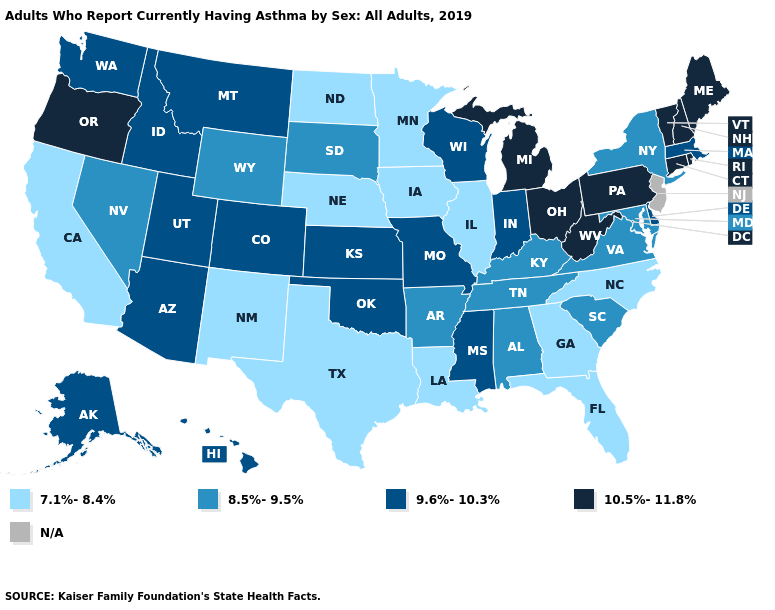Is the legend a continuous bar?
Give a very brief answer. No. What is the value of Alabama?
Concise answer only. 8.5%-9.5%. Name the states that have a value in the range N/A?
Quick response, please. New Jersey. How many symbols are there in the legend?
Keep it brief. 5. What is the value of Kentucky?
Quick response, please. 8.5%-9.5%. Among the states that border Massachusetts , does New York have the lowest value?
Short answer required. Yes. Which states have the highest value in the USA?
Concise answer only. Connecticut, Maine, Michigan, New Hampshire, Ohio, Oregon, Pennsylvania, Rhode Island, Vermont, West Virginia. Name the states that have a value in the range 7.1%-8.4%?
Keep it brief. California, Florida, Georgia, Illinois, Iowa, Louisiana, Minnesota, Nebraska, New Mexico, North Carolina, North Dakota, Texas. What is the value of Kansas?
Keep it brief. 9.6%-10.3%. Does the first symbol in the legend represent the smallest category?
Answer briefly. Yes. Name the states that have a value in the range 10.5%-11.8%?
Quick response, please. Connecticut, Maine, Michigan, New Hampshire, Ohio, Oregon, Pennsylvania, Rhode Island, Vermont, West Virginia. What is the value of Washington?
Be succinct. 9.6%-10.3%. What is the lowest value in the USA?
Keep it brief. 7.1%-8.4%. What is the value of Illinois?
Write a very short answer. 7.1%-8.4%. 